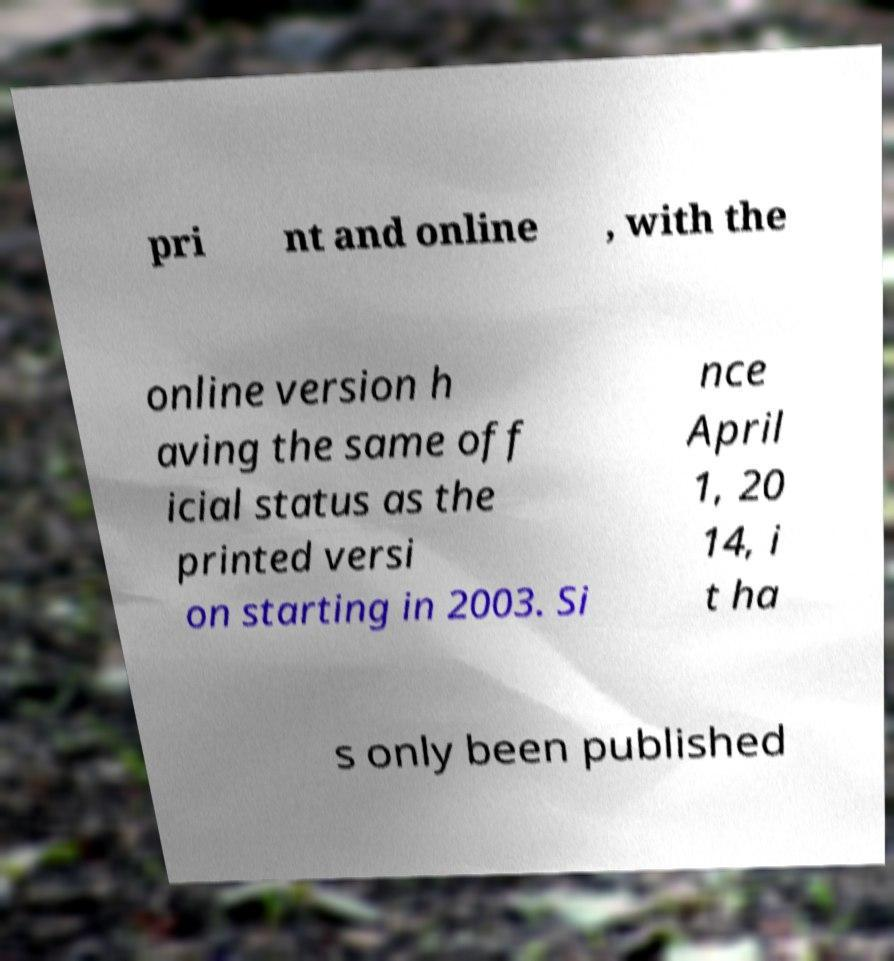There's text embedded in this image that I need extracted. Can you transcribe it verbatim? pri nt and online , with the online version h aving the same off icial status as the printed versi on starting in 2003. Si nce April 1, 20 14, i t ha s only been published 